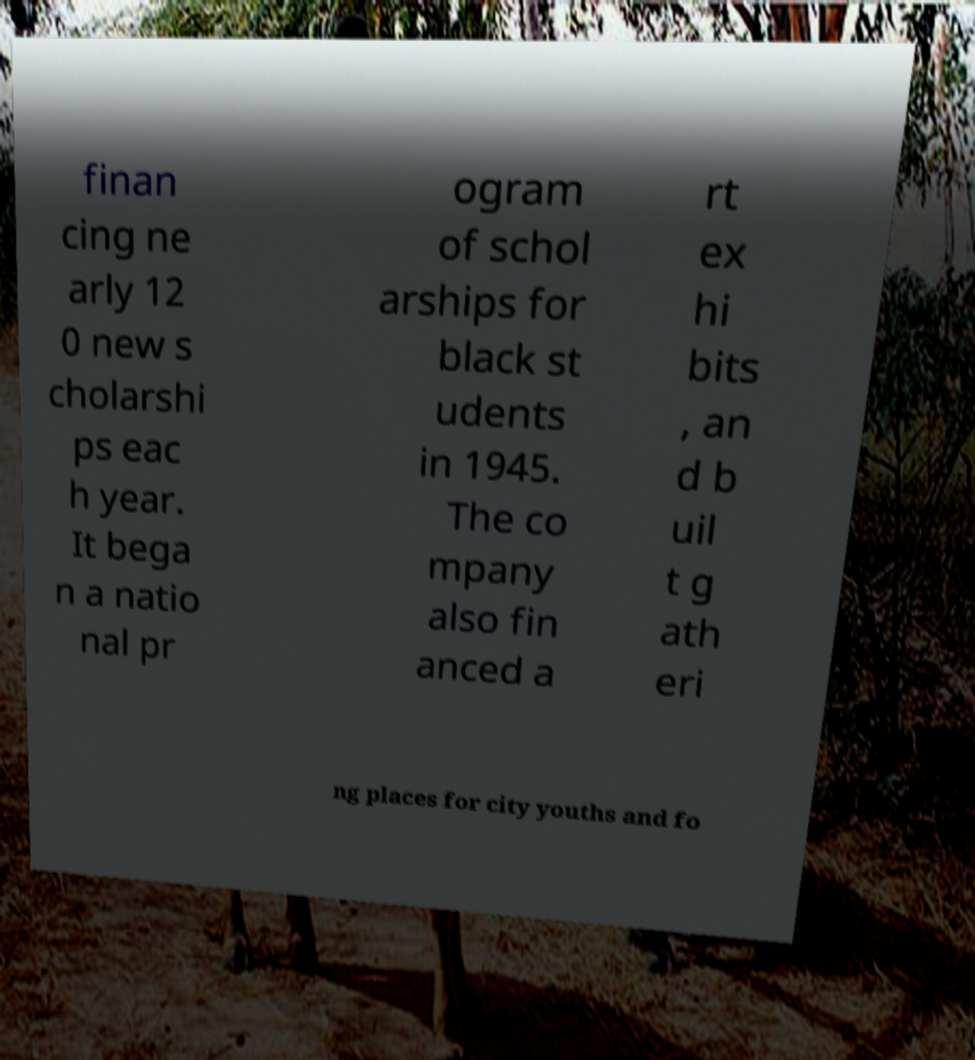Can you read and provide the text displayed in the image?This photo seems to have some interesting text. Can you extract and type it out for me? finan cing ne arly 12 0 new s cholarshi ps eac h year. It bega n a natio nal pr ogram of schol arships for black st udents in 1945. The co mpany also fin anced a rt ex hi bits , an d b uil t g ath eri ng places for city youths and fo 